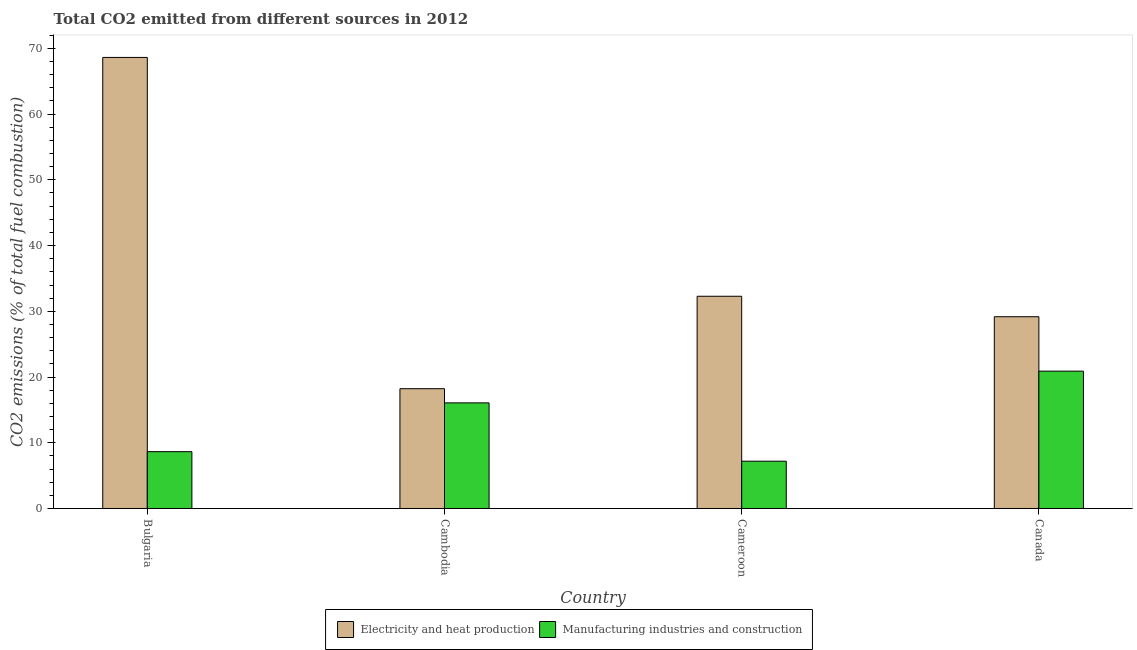How many different coloured bars are there?
Provide a succinct answer. 2. Are the number of bars on each tick of the X-axis equal?
Offer a terse response. Yes. How many bars are there on the 1st tick from the left?
Make the answer very short. 2. How many bars are there on the 2nd tick from the right?
Ensure brevity in your answer.  2. What is the label of the 1st group of bars from the left?
Offer a terse response. Bulgaria. What is the co2 emissions due to manufacturing industries in Cameroon?
Make the answer very short. 7.2. Across all countries, what is the maximum co2 emissions due to electricity and heat production?
Ensure brevity in your answer.  68.62. Across all countries, what is the minimum co2 emissions due to electricity and heat production?
Your answer should be very brief. 18.23. In which country was the co2 emissions due to electricity and heat production minimum?
Your response must be concise. Cambodia. What is the total co2 emissions due to electricity and heat production in the graph?
Offer a terse response. 148.31. What is the difference between the co2 emissions due to electricity and heat production in Cameroon and that in Canada?
Your answer should be compact. 3.11. What is the difference between the co2 emissions due to electricity and heat production in Cambodia and the co2 emissions due to manufacturing industries in Bulgaria?
Make the answer very short. 9.58. What is the average co2 emissions due to electricity and heat production per country?
Your answer should be compact. 37.08. What is the difference between the co2 emissions due to manufacturing industries and co2 emissions due to electricity and heat production in Cameroon?
Give a very brief answer. -25.09. In how many countries, is the co2 emissions due to manufacturing industries greater than 48 %?
Your response must be concise. 0. What is the ratio of the co2 emissions due to manufacturing industries in Bulgaria to that in Cameroon?
Provide a short and direct response. 1.2. Is the co2 emissions due to manufacturing industries in Bulgaria less than that in Cameroon?
Provide a succinct answer. No. What is the difference between the highest and the second highest co2 emissions due to electricity and heat production?
Provide a succinct answer. 36.34. What is the difference between the highest and the lowest co2 emissions due to electricity and heat production?
Offer a terse response. 50.4. In how many countries, is the co2 emissions due to manufacturing industries greater than the average co2 emissions due to manufacturing industries taken over all countries?
Your answer should be very brief. 2. What does the 2nd bar from the left in Bulgaria represents?
Provide a succinct answer. Manufacturing industries and construction. What does the 1st bar from the right in Cambodia represents?
Your answer should be very brief. Manufacturing industries and construction. Does the graph contain any zero values?
Provide a short and direct response. No. How many legend labels are there?
Keep it short and to the point. 2. What is the title of the graph?
Provide a short and direct response. Total CO2 emitted from different sources in 2012. What is the label or title of the X-axis?
Your answer should be very brief. Country. What is the label or title of the Y-axis?
Make the answer very short. CO2 emissions (% of total fuel combustion). What is the CO2 emissions (% of total fuel combustion) in Electricity and heat production in Bulgaria?
Offer a terse response. 68.62. What is the CO2 emissions (% of total fuel combustion) of Manufacturing industries and construction in Bulgaria?
Your response must be concise. 8.65. What is the CO2 emissions (% of total fuel combustion) of Electricity and heat production in Cambodia?
Your response must be concise. 18.23. What is the CO2 emissions (% of total fuel combustion) of Manufacturing industries and construction in Cambodia?
Provide a succinct answer. 16.07. What is the CO2 emissions (% of total fuel combustion) of Electricity and heat production in Cameroon?
Offer a very short reply. 32.29. What is the CO2 emissions (% of total fuel combustion) of Manufacturing industries and construction in Cameroon?
Keep it short and to the point. 7.2. What is the CO2 emissions (% of total fuel combustion) of Electricity and heat production in Canada?
Give a very brief answer. 29.17. What is the CO2 emissions (% of total fuel combustion) of Manufacturing industries and construction in Canada?
Your answer should be compact. 20.89. Across all countries, what is the maximum CO2 emissions (% of total fuel combustion) in Electricity and heat production?
Provide a short and direct response. 68.62. Across all countries, what is the maximum CO2 emissions (% of total fuel combustion) of Manufacturing industries and construction?
Ensure brevity in your answer.  20.89. Across all countries, what is the minimum CO2 emissions (% of total fuel combustion) of Electricity and heat production?
Give a very brief answer. 18.23. Across all countries, what is the minimum CO2 emissions (% of total fuel combustion) of Manufacturing industries and construction?
Your response must be concise. 7.2. What is the total CO2 emissions (% of total fuel combustion) in Electricity and heat production in the graph?
Provide a short and direct response. 148.31. What is the total CO2 emissions (% of total fuel combustion) of Manufacturing industries and construction in the graph?
Provide a short and direct response. 52.8. What is the difference between the CO2 emissions (% of total fuel combustion) of Electricity and heat production in Bulgaria and that in Cambodia?
Your answer should be compact. 50.4. What is the difference between the CO2 emissions (% of total fuel combustion) of Manufacturing industries and construction in Bulgaria and that in Cambodia?
Give a very brief answer. -7.42. What is the difference between the CO2 emissions (% of total fuel combustion) in Electricity and heat production in Bulgaria and that in Cameroon?
Keep it short and to the point. 36.34. What is the difference between the CO2 emissions (% of total fuel combustion) in Manufacturing industries and construction in Bulgaria and that in Cameroon?
Make the answer very short. 1.45. What is the difference between the CO2 emissions (% of total fuel combustion) in Electricity and heat production in Bulgaria and that in Canada?
Your response must be concise. 39.45. What is the difference between the CO2 emissions (% of total fuel combustion) of Manufacturing industries and construction in Bulgaria and that in Canada?
Offer a very short reply. -12.25. What is the difference between the CO2 emissions (% of total fuel combustion) of Electricity and heat production in Cambodia and that in Cameroon?
Give a very brief answer. -14.06. What is the difference between the CO2 emissions (% of total fuel combustion) of Manufacturing industries and construction in Cambodia and that in Cameroon?
Provide a succinct answer. 8.87. What is the difference between the CO2 emissions (% of total fuel combustion) in Electricity and heat production in Cambodia and that in Canada?
Make the answer very short. -10.95. What is the difference between the CO2 emissions (% of total fuel combustion) in Manufacturing industries and construction in Cambodia and that in Canada?
Offer a very short reply. -4.83. What is the difference between the CO2 emissions (% of total fuel combustion) in Electricity and heat production in Cameroon and that in Canada?
Offer a very short reply. 3.11. What is the difference between the CO2 emissions (% of total fuel combustion) of Manufacturing industries and construction in Cameroon and that in Canada?
Your response must be concise. -13.7. What is the difference between the CO2 emissions (% of total fuel combustion) of Electricity and heat production in Bulgaria and the CO2 emissions (% of total fuel combustion) of Manufacturing industries and construction in Cambodia?
Offer a very short reply. 52.56. What is the difference between the CO2 emissions (% of total fuel combustion) in Electricity and heat production in Bulgaria and the CO2 emissions (% of total fuel combustion) in Manufacturing industries and construction in Cameroon?
Your answer should be compact. 61.43. What is the difference between the CO2 emissions (% of total fuel combustion) in Electricity and heat production in Bulgaria and the CO2 emissions (% of total fuel combustion) in Manufacturing industries and construction in Canada?
Offer a very short reply. 47.73. What is the difference between the CO2 emissions (% of total fuel combustion) in Electricity and heat production in Cambodia and the CO2 emissions (% of total fuel combustion) in Manufacturing industries and construction in Cameroon?
Ensure brevity in your answer.  11.03. What is the difference between the CO2 emissions (% of total fuel combustion) in Electricity and heat production in Cambodia and the CO2 emissions (% of total fuel combustion) in Manufacturing industries and construction in Canada?
Ensure brevity in your answer.  -2.67. What is the difference between the CO2 emissions (% of total fuel combustion) in Electricity and heat production in Cameroon and the CO2 emissions (% of total fuel combustion) in Manufacturing industries and construction in Canada?
Offer a very short reply. 11.39. What is the average CO2 emissions (% of total fuel combustion) in Electricity and heat production per country?
Your response must be concise. 37.08. What is the average CO2 emissions (% of total fuel combustion) of Manufacturing industries and construction per country?
Provide a succinct answer. 13.2. What is the difference between the CO2 emissions (% of total fuel combustion) of Electricity and heat production and CO2 emissions (% of total fuel combustion) of Manufacturing industries and construction in Bulgaria?
Your response must be concise. 59.98. What is the difference between the CO2 emissions (% of total fuel combustion) in Electricity and heat production and CO2 emissions (% of total fuel combustion) in Manufacturing industries and construction in Cambodia?
Provide a succinct answer. 2.16. What is the difference between the CO2 emissions (% of total fuel combustion) in Electricity and heat production and CO2 emissions (% of total fuel combustion) in Manufacturing industries and construction in Cameroon?
Make the answer very short. 25.09. What is the difference between the CO2 emissions (% of total fuel combustion) of Electricity and heat production and CO2 emissions (% of total fuel combustion) of Manufacturing industries and construction in Canada?
Ensure brevity in your answer.  8.28. What is the ratio of the CO2 emissions (% of total fuel combustion) in Electricity and heat production in Bulgaria to that in Cambodia?
Offer a terse response. 3.77. What is the ratio of the CO2 emissions (% of total fuel combustion) of Manufacturing industries and construction in Bulgaria to that in Cambodia?
Ensure brevity in your answer.  0.54. What is the ratio of the CO2 emissions (% of total fuel combustion) of Electricity and heat production in Bulgaria to that in Cameroon?
Ensure brevity in your answer.  2.13. What is the ratio of the CO2 emissions (% of total fuel combustion) of Manufacturing industries and construction in Bulgaria to that in Cameroon?
Give a very brief answer. 1.2. What is the ratio of the CO2 emissions (% of total fuel combustion) of Electricity and heat production in Bulgaria to that in Canada?
Your response must be concise. 2.35. What is the ratio of the CO2 emissions (% of total fuel combustion) in Manufacturing industries and construction in Bulgaria to that in Canada?
Give a very brief answer. 0.41. What is the ratio of the CO2 emissions (% of total fuel combustion) in Electricity and heat production in Cambodia to that in Cameroon?
Your answer should be compact. 0.56. What is the ratio of the CO2 emissions (% of total fuel combustion) in Manufacturing industries and construction in Cambodia to that in Cameroon?
Ensure brevity in your answer.  2.23. What is the ratio of the CO2 emissions (% of total fuel combustion) of Electricity and heat production in Cambodia to that in Canada?
Ensure brevity in your answer.  0.62. What is the ratio of the CO2 emissions (% of total fuel combustion) of Manufacturing industries and construction in Cambodia to that in Canada?
Ensure brevity in your answer.  0.77. What is the ratio of the CO2 emissions (% of total fuel combustion) of Electricity and heat production in Cameroon to that in Canada?
Provide a short and direct response. 1.11. What is the ratio of the CO2 emissions (% of total fuel combustion) in Manufacturing industries and construction in Cameroon to that in Canada?
Offer a terse response. 0.34. What is the difference between the highest and the second highest CO2 emissions (% of total fuel combustion) of Electricity and heat production?
Make the answer very short. 36.34. What is the difference between the highest and the second highest CO2 emissions (% of total fuel combustion) of Manufacturing industries and construction?
Your response must be concise. 4.83. What is the difference between the highest and the lowest CO2 emissions (% of total fuel combustion) of Electricity and heat production?
Provide a succinct answer. 50.4. What is the difference between the highest and the lowest CO2 emissions (% of total fuel combustion) of Manufacturing industries and construction?
Offer a very short reply. 13.7. 